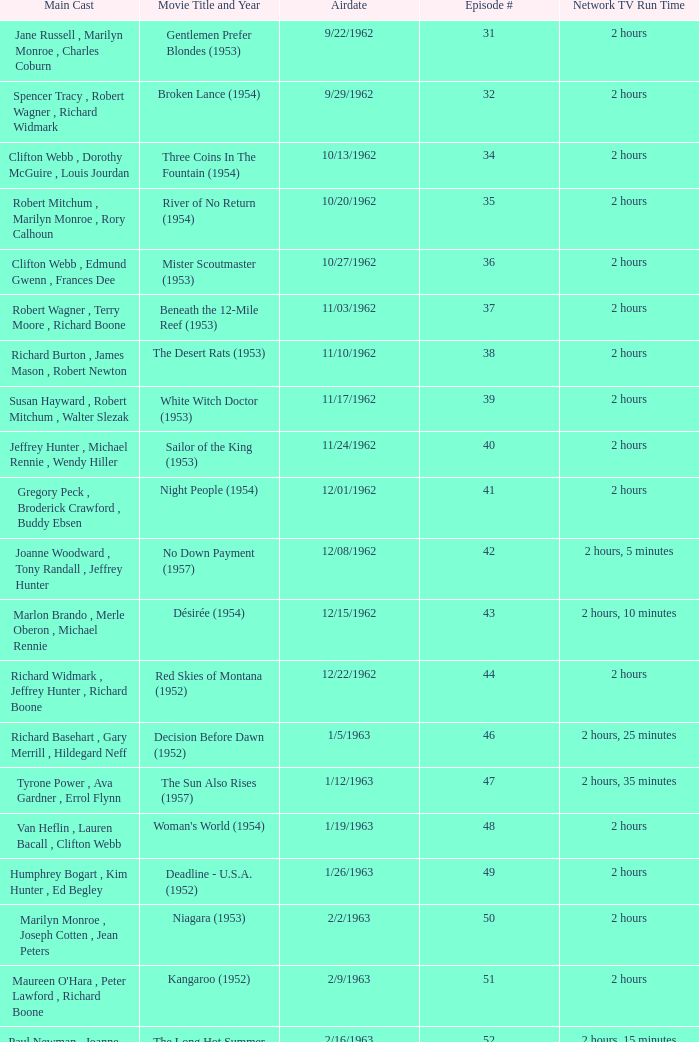Who was the cast on the 3/23/1963 episode? Dana Wynter , Mel Ferrer , Theodore Bikel. 